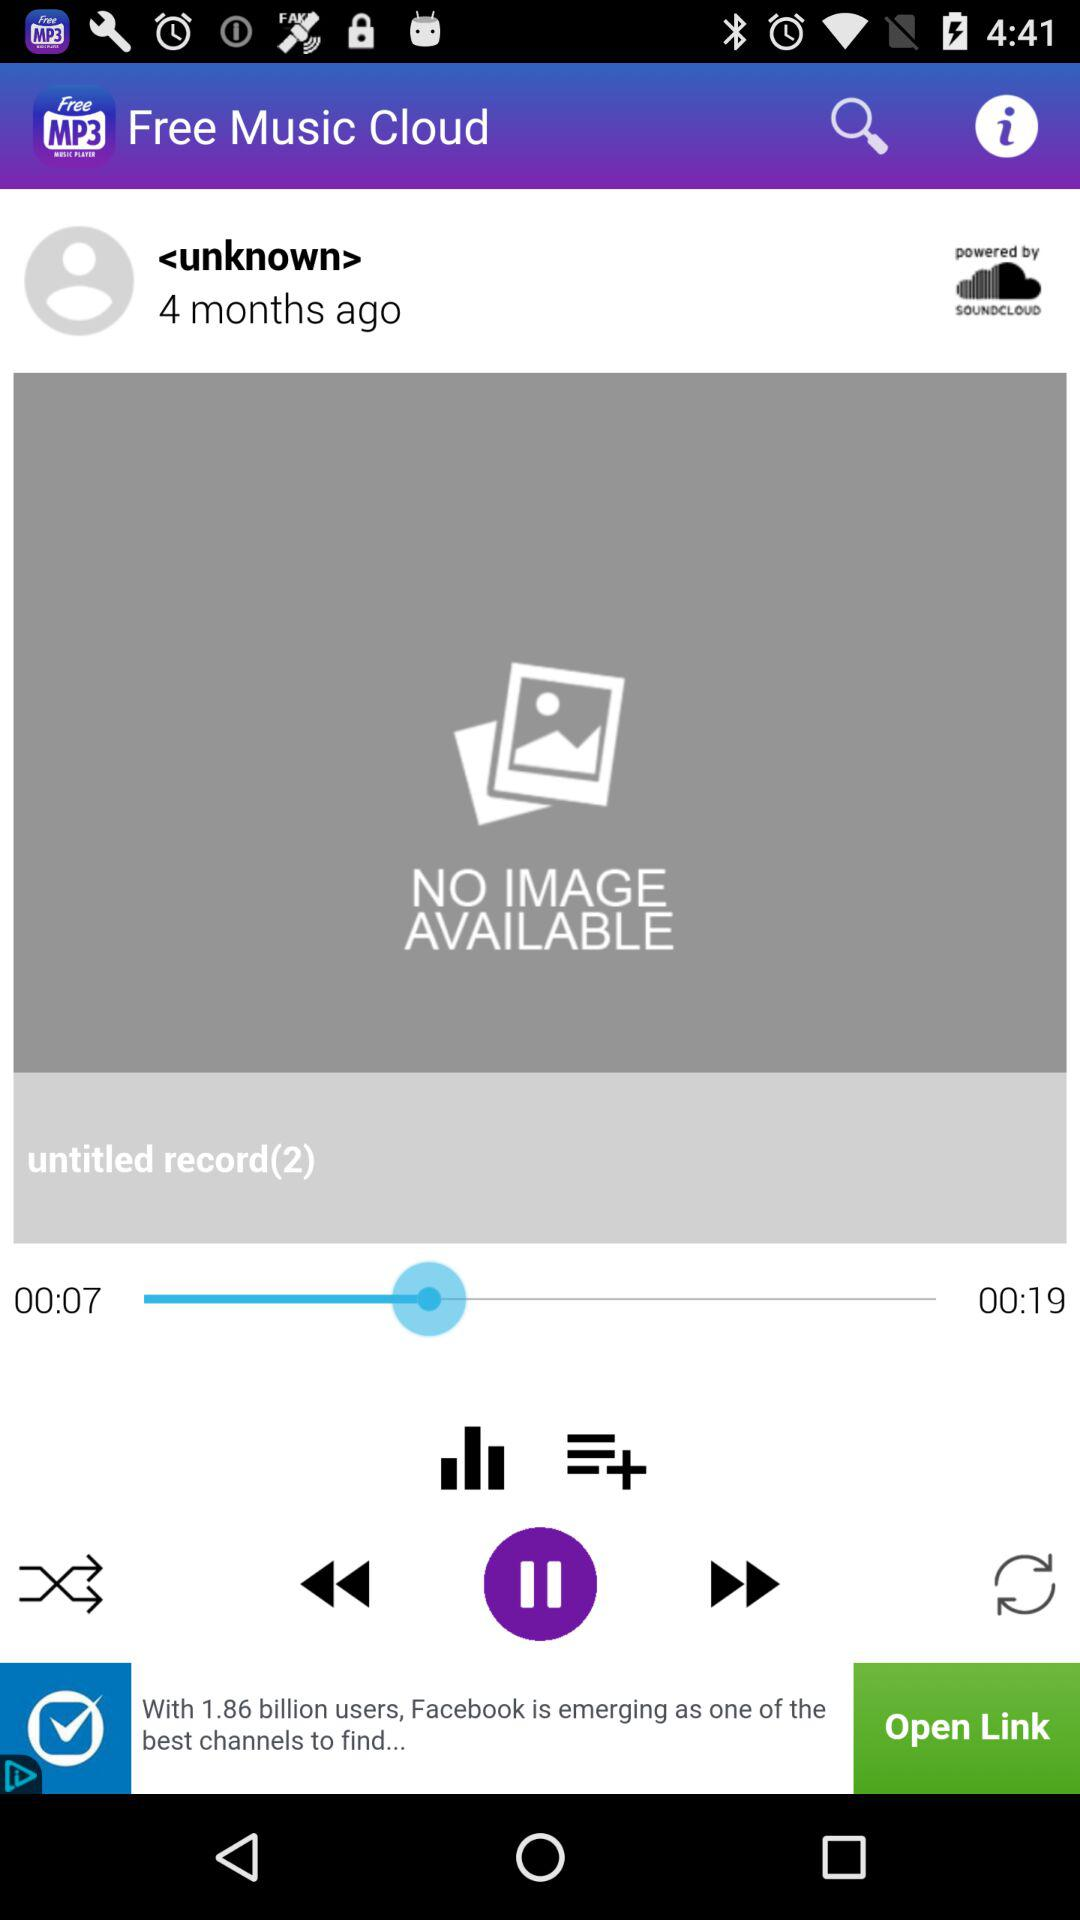How many months ago did the unknown user post? The unknown user posted 4 months ago. 